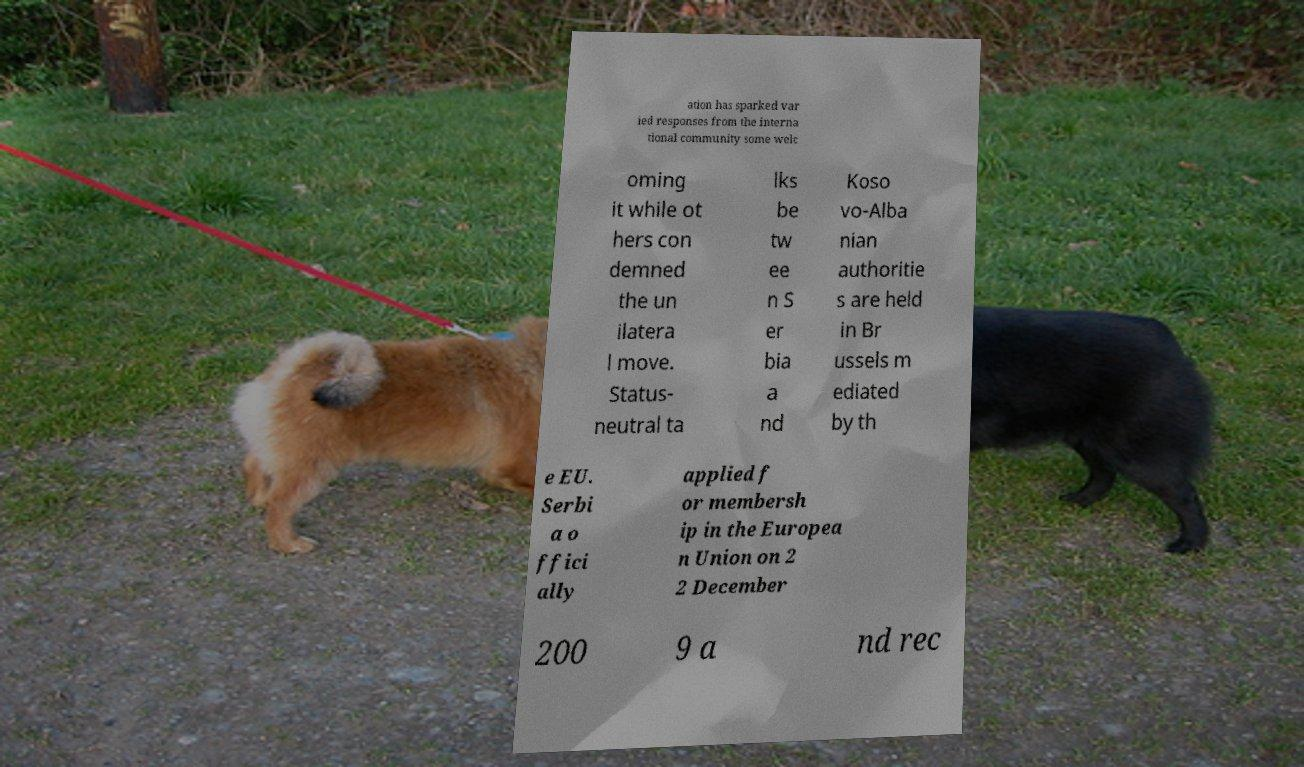Can you read and provide the text displayed in the image?This photo seems to have some interesting text. Can you extract and type it out for me? ation has sparked var ied responses from the interna tional community some welc oming it while ot hers con demned the un ilatera l move. Status- neutral ta lks be tw ee n S er bia a nd Koso vo-Alba nian authoritie s are held in Br ussels m ediated by th e EU. Serbi a o ffici ally applied f or membersh ip in the Europea n Union on 2 2 December 200 9 a nd rec 